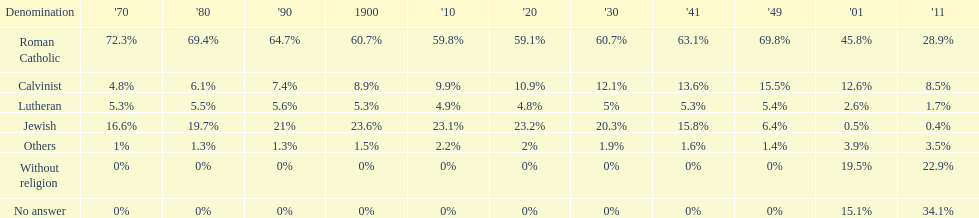Which denomination percentage increased the most after 1949? Without religion. 